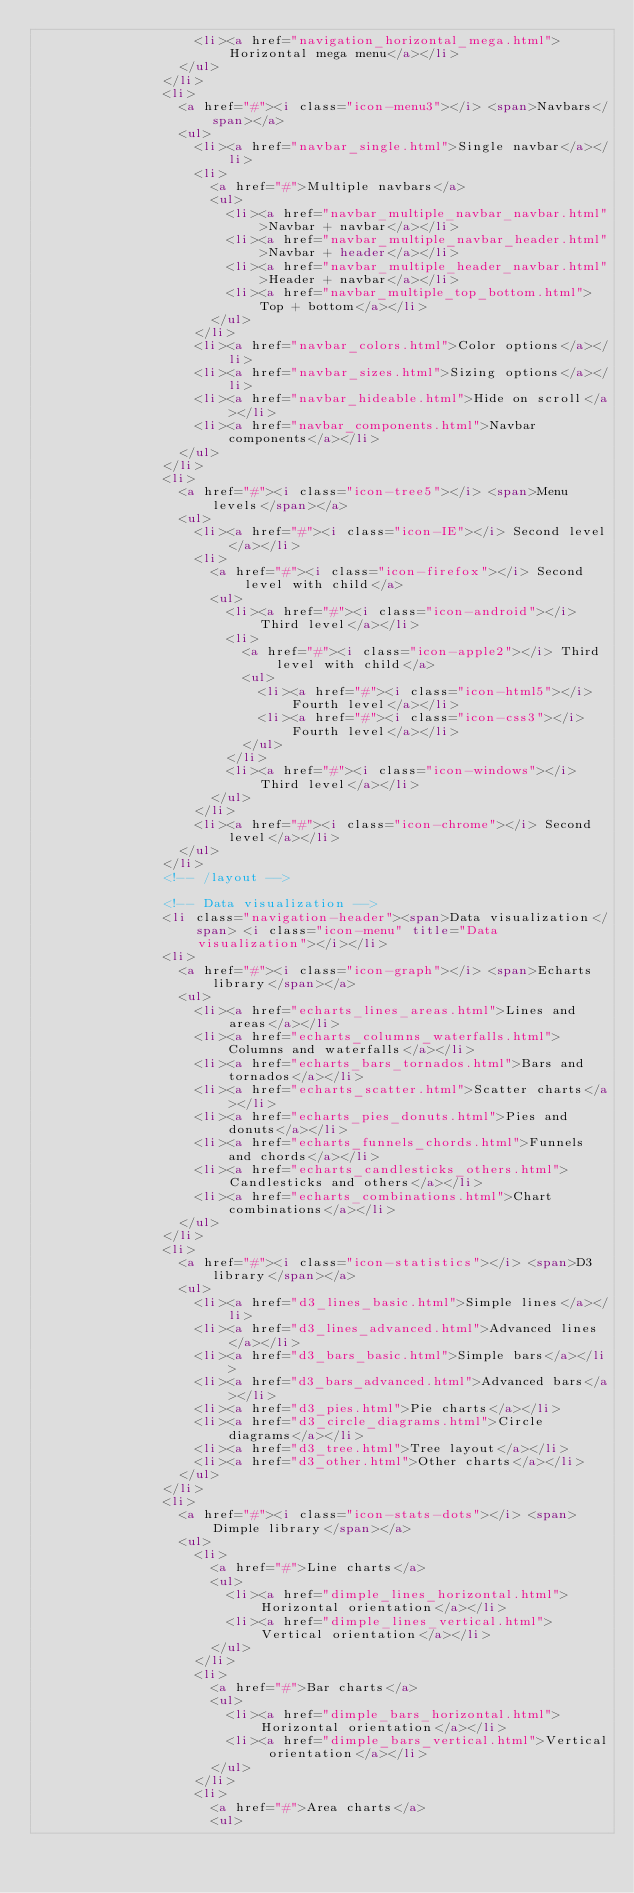Convert code to text. <code><loc_0><loc_0><loc_500><loc_500><_HTML_>										<li><a href="navigation_horizontal_mega.html">Horizontal mega menu</a></li>
									</ul>
								</li>
								<li>
									<a href="#"><i class="icon-menu3"></i> <span>Navbars</span></a>
									<ul>
										<li><a href="navbar_single.html">Single navbar</a></li>
										<li>
											<a href="#">Multiple navbars</a>
											<ul>
												<li><a href="navbar_multiple_navbar_navbar.html">Navbar + navbar</a></li>
												<li><a href="navbar_multiple_navbar_header.html">Navbar + header</a></li>
												<li><a href="navbar_multiple_header_navbar.html">Header + navbar</a></li>
												<li><a href="navbar_multiple_top_bottom.html">Top + bottom</a></li>
											</ul>
										</li>
										<li><a href="navbar_colors.html">Color options</a></li>
										<li><a href="navbar_sizes.html">Sizing options</a></li>
										<li><a href="navbar_hideable.html">Hide on scroll</a></li>
										<li><a href="navbar_components.html">Navbar components</a></li>
									</ul>
								</li>
								<li>
									<a href="#"><i class="icon-tree5"></i> <span>Menu levels</span></a>
									<ul>
										<li><a href="#"><i class="icon-IE"></i> Second level</a></li>
										<li>
											<a href="#"><i class="icon-firefox"></i> Second level with child</a>
											<ul>
												<li><a href="#"><i class="icon-android"></i> Third level</a></li>
												<li>
													<a href="#"><i class="icon-apple2"></i> Third level with child</a>
													<ul>
														<li><a href="#"><i class="icon-html5"></i> Fourth level</a></li>
														<li><a href="#"><i class="icon-css3"></i> Fourth level</a></li>
													</ul>
												</li>
												<li><a href="#"><i class="icon-windows"></i> Third level</a></li>
											</ul>
										</li>
										<li><a href="#"><i class="icon-chrome"></i> Second level</a></li>
									</ul>
								</li>
								<!-- /layout -->

								<!-- Data visualization -->
								<li class="navigation-header"><span>Data visualization</span> <i class="icon-menu" title="Data visualization"></i></li>
								<li>
									<a href="#"><i class="icon-graph"></i> <span>Echarts library</span></a>
									<ul>
										<li><a href="echarts_lines_areas.html">Lines and areas</a></li>
										<li><a href="echarts_columns_waterfalls.html">Columns and waterfalls</a></li>
										<li><a href="echarts_bars_tornados.html">Bars and tornados</a></li>
										<li><a href="echarts_scatter.html">Scatter charts</a></li>
										<li><a href="echarts_pies_donuts.html">Pies and donuts</a></li>
										<li><a href="echarts_funnels_chords.html">Funnels and chords</a></li>
										<li><a href="echarts_candlesticks_others.html">Candlesticks and others</a></li>
										<li><a href="echarts_combinations.html">Chart combinations</a></li>
									</ul>
								</li>
								<li>
									<a href="#"><i class="icon-statistics"></i> <span>D3 library</span></a>
									<ul>
										<li><a href="d3_lines_basic.html">Simple lines</a></li>
										<li><a href="d3_lines_advanced.html">Advanced lines</a></li>
										<li><a href="d3_bars_basic.html">Simple bars</a></li>
										<li><a href="d3_bars_advanced.html">Advanced bars</a></li>
										<li><a href="d3_pies.html">Pie charts</a></li>
										<li><a href="d3_circle_diagrams.html">Circle diagrams</a></li>
										<li><a href="d3_tree.html">Tree layout</a></li>
										<li><a href="d3_other.html">Other charts</a></li>
									</ul>
								</li>
								<li>
									<a href="#"><i class="icon-stats-dots"></i> <span>Dimple library</span></a>
									<ul>
										<li>
											<a href="#">Line charts</a>
											<ul>
												<li><a href="dimple_lines_horizontal.html">Horizontal orientation</a></li>
												<li><a href="dimple_lines_vertical.html">Vertical orientation</a></li>
											</ul>
										</li>
										<li>
											<a href="#">Bar charts</a>
											<ul>
												<li><a href="dimple_bars_horizontal.html">Horizontal orientation</a></li>
												<li><a href="dimple_bars_vertical.html">Vertical orientation</a></li>
											</ul>
										</li>
										<li>
											<a href="#">Area charts</a>
											<ul></code> 